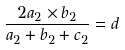<formula> <loc_0><loc_0><loc_500><loc_500>\frac { 2 a _ { 2 } \times b _ { 2 } } { a _ { 2 } + b _ { 2 } + c _ { 2 } } = d</formula> 